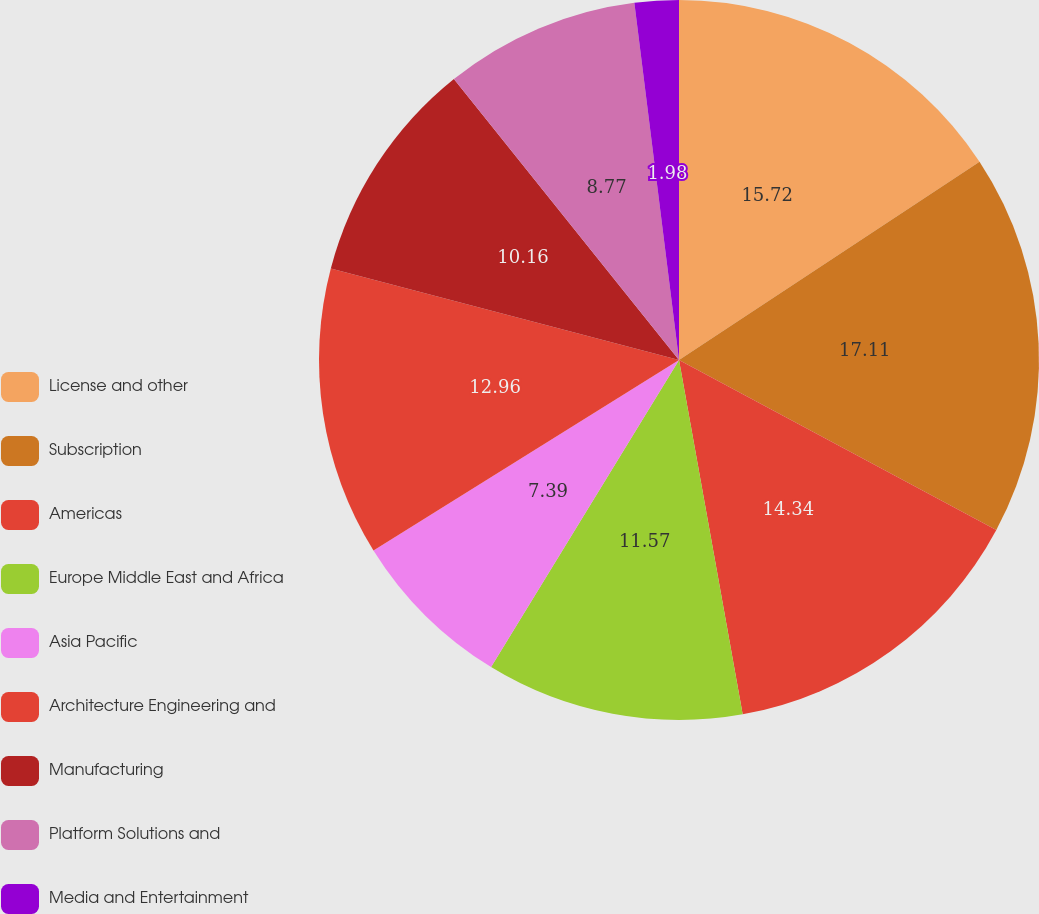Convert chart to OTSL. <chart><loc_0><loc_0><loc_500><loc_500><pie_chart><fcel>License and other<fcel>Subscription<fcel>Americas<fcel>Europe Middle East and Africa<fcel>Asia Pacific<fcel>Architecture Engineering and<fcel>Manufacturing<fcel>Platform Solutions and<fcel>Media and Entertainment<nl><fcel>15.72%<fcel>17.11%<fcel>14.34%<fcel>11.57%<fcel>7.39%<fcel>12.96%<fcel>10.16%<fcel>8.77%<fcel>1.98%<nl></chart> 